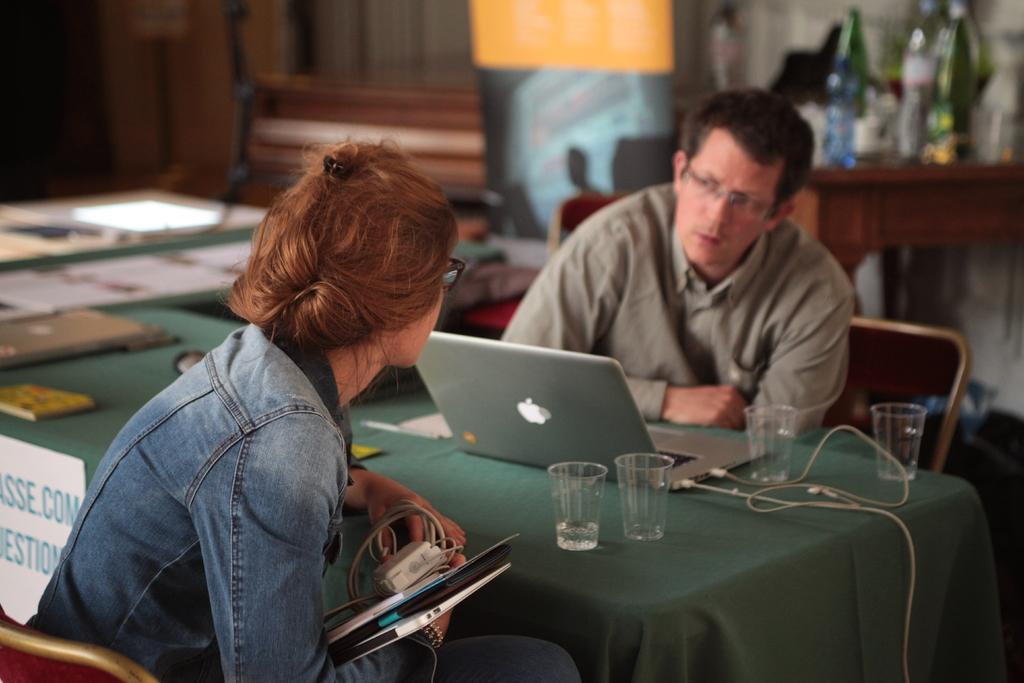How would you summarize this image in a sentence or two? In the image we can see there are two people who are sitting on chair and there is a laptop on the table and there are four glasses near the laptop. 